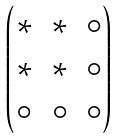Convert formula to latex. <formula><loc_0><loc_0><loc_500><loc_500>\begin{pmatrix} \ast & \ast & \circ \\ \ast & \ast & \circ \\ \circ & \circ & \circ \end{pmatrix}</formula> 